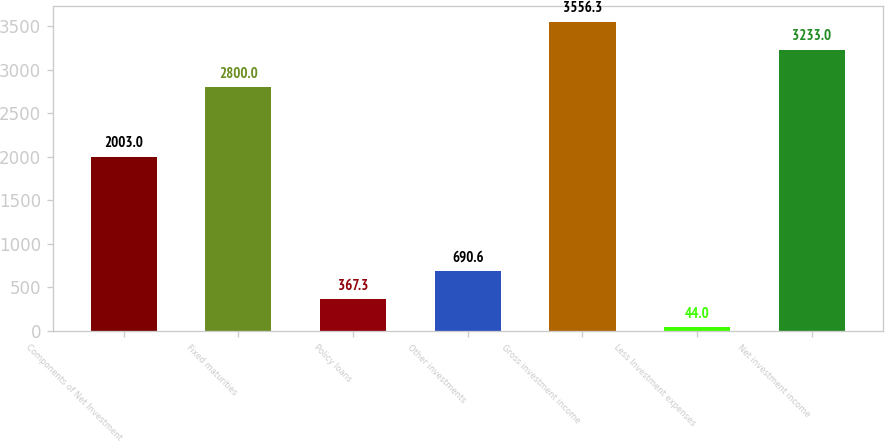Convert chart to OTSL. <chart><loc_0><loc_0><loc_500><loc_500><bar_chart><fcel>Components of Net Investment<fcel>Fixed maturities<fcel>Policy loans<fcel>Other investments<fcel>Gross investment income<fcel>Less Investment expenses<fcel>Net investment income<nl><fcel>2003<fcel>2800<fcel>367.3<fcel>690.6<fcel>3556.3<fcel>44<fcel>3233<nl></chart> 